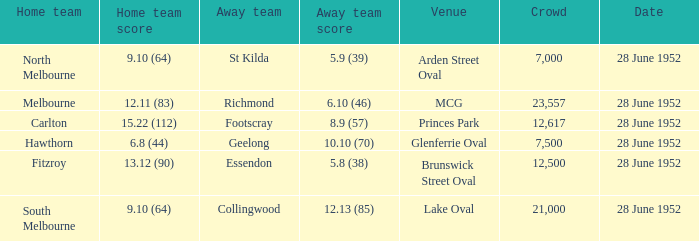10 (64)? St Kilda. 